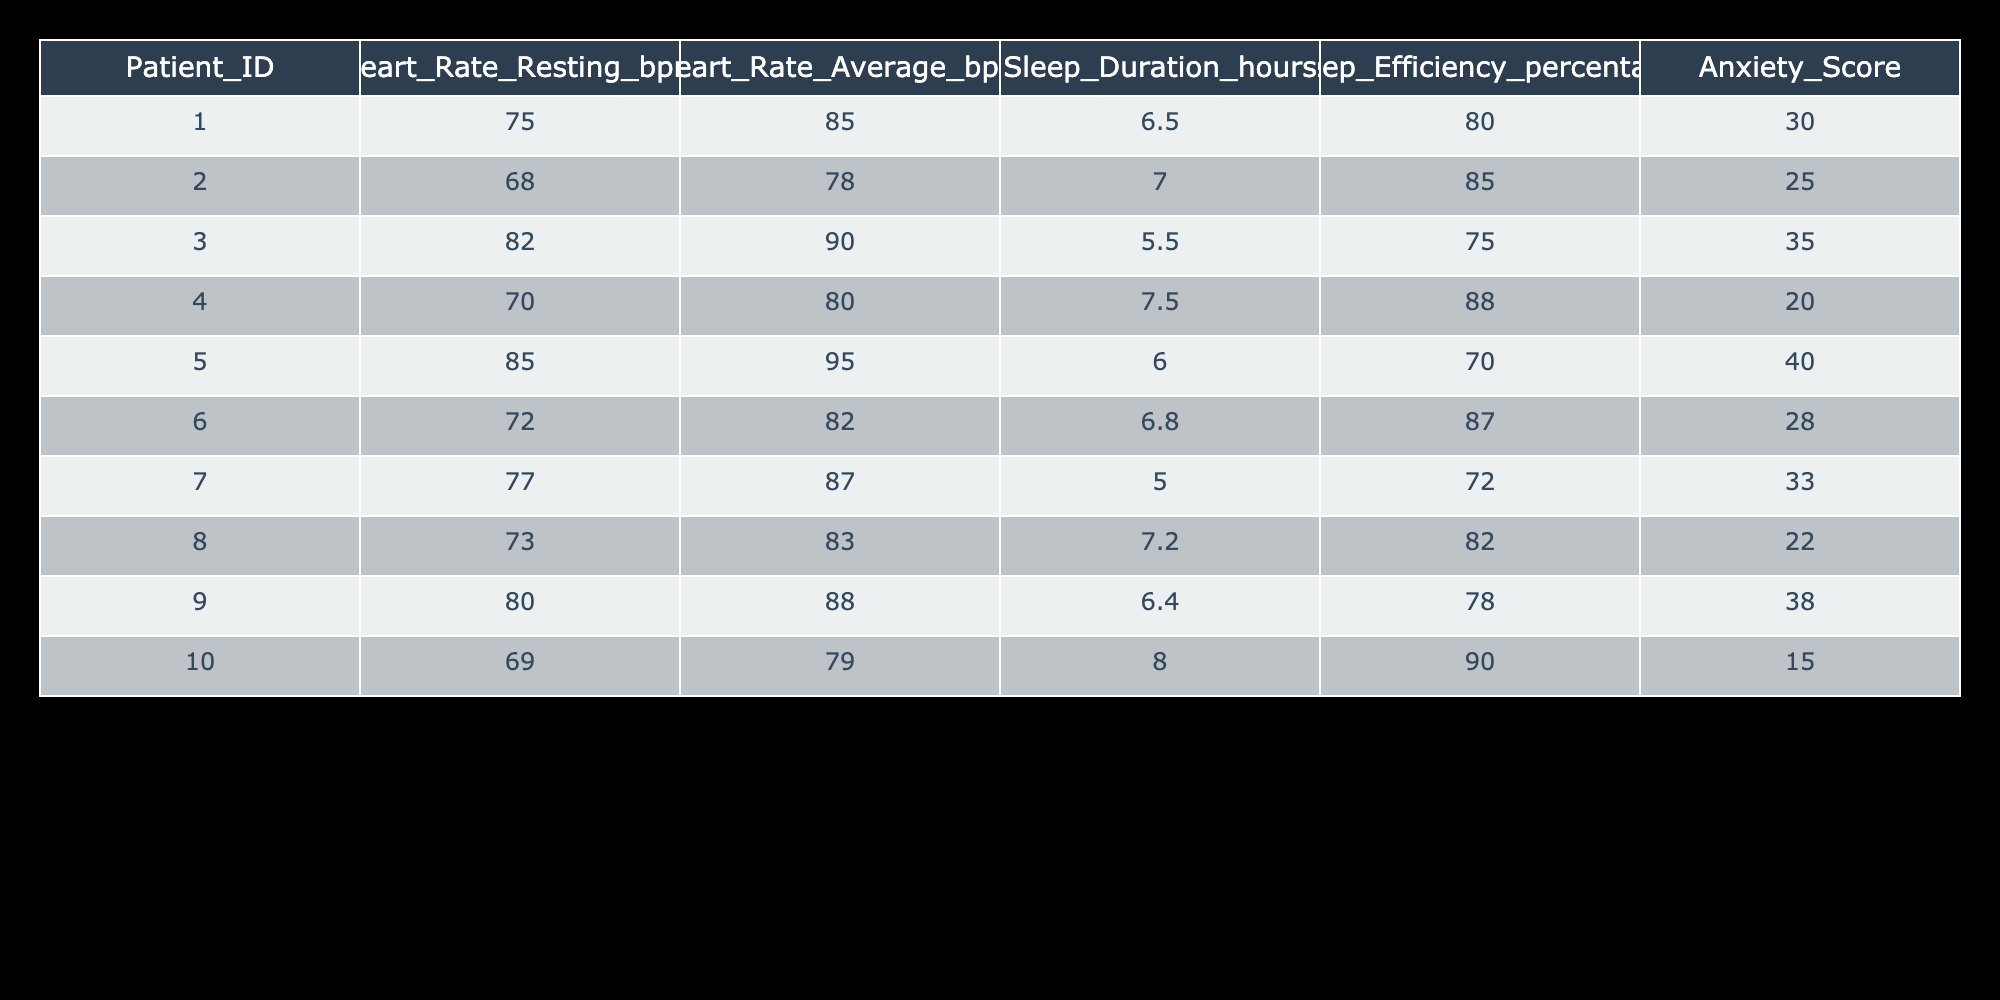What is the resting heart rate of patient ID 001? According to the table, the resting heart rate of patient ID 001 is explicitly listed in the Heart_Rate_Resting_bpm column. The value is 75 bpm.
Answer: 75 bpm What is the average anxiety score of all patients? To calculate the average anxiety score, sum all the anxiety scores: (30 + 25 + 35 + 20 + 40 + 28 + 33 + 22 + 38 + 15) =  336. Then, divide by the number of patients (10): 336 / 10 = 33.6.
Answer: 33.6 Is the sleep efficiency of patient ID 006 greater than that of patient ID 004? Looking at the Sleep_Efficiency_percentage for both patients, patient ID 006 has 87%, and patient ID 004 has 88%. Since 87 is less than 88, the statement is false.
Answer: No Which patient has the highest average heart rate? To find the highest average heart rate, I will compare the Average_bpm values: The averages are 85, 78, 90, 80, 95, 82, 87, 83, 88, and 79. The maximum value is 95 bpm, corresponding to patient ID 005.
Answer: Patient ID 005 What is the median sleep duration for the patients? First, we list all the Sleep_Duration_hours values in order: 5.0, 5.5, 6.0, 6.4, 6.5, 6.8, 7.0, 7.2, 7.5, 8.0. There are 10 values, and the median will be the average of the 5th and 6th values: (6.5 + 6.8) / 2 = 6.65 hours.
Answer: 6.65 hours Does patient ID 010 have the lowest anxiety score? By reviewing the Anxiety_Score for all patients, patient ID 010 has a score of 15. No other score is lower than 15 among the listed values. Therefore, the statement is true.
Answer: Yes What is the difference between the highest and lowest resting heart rates reported in the table? The highest resting heart rate is 85 bpm (patient ID 005) and the lowest is 68 bpm (patient ID 002). The difference is calculated as 85 - 68 = 17 bpm.
Answer: 17 bpm How many patients have a sleep efficiency percentage below 80? Reviewing the Sleep_Efficiency_percentage column, the values below 80% are for patient ID 003 (75%), patient ID 005 (70%), and patient ID 007 (72%). Thus, three patients have below 80%.
Answer: 3 What is the average sleep duration for patients with an anxiety score greater than 30? The patients with anxiety scores greater than 30 are patient ID 003 (5.5 hours), patient ID 005 (6.0 hours), patient ID 007 (5.0 hours), and patient ID 009 (6.4 hours). The average is calculated by summing these durations: (5.5 + 6.0 + 5.0 + 6.4) = 22.9, and dividing by 4 gives 22.9 / 4 = 5.725 hours.
Answer: 5.725 hours 